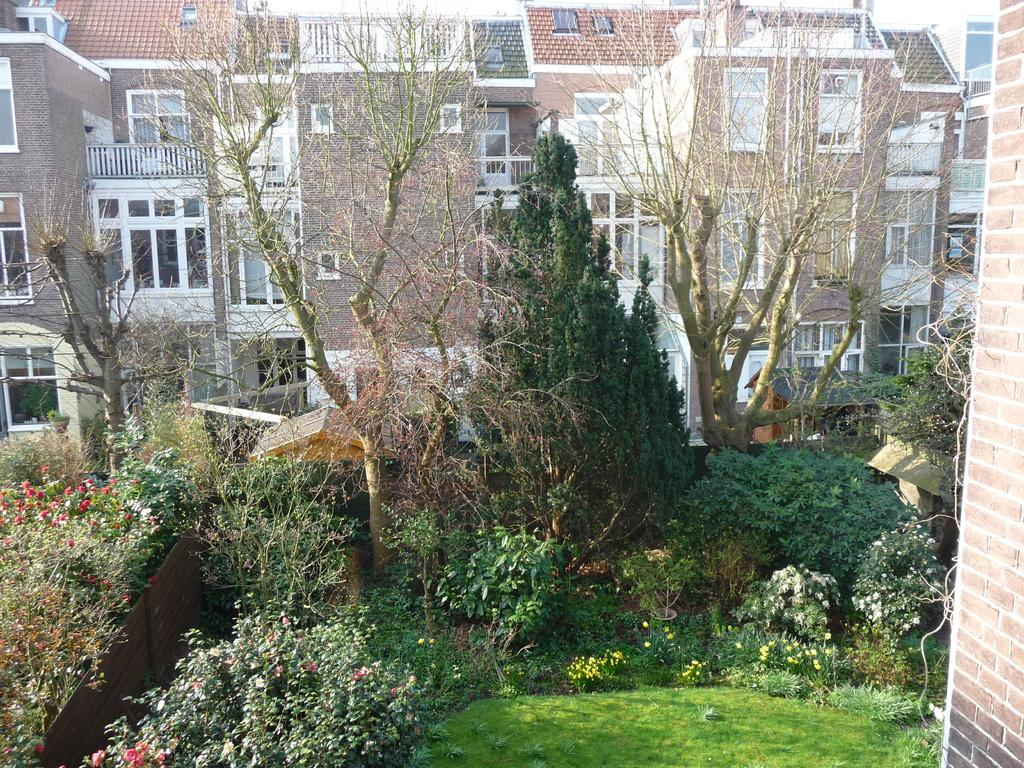What type of vegetation can be seen in the image? There are plants, flowers, and trees in the image. What type of ground cover is present in the image? There is grass in the image. What can be seen in the background of the image? There are buildings in the background of the image. Where is the sink located in the image? There is no sink present in the image. What type of ice can be seen melting on the flowers in the image? There is no ice present in the image; it features plants, flowers, and trees without any ice. 